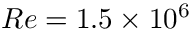Convert formula to latex. <formula><loc_0><loc_0><loc_500><loc_500>R e = 1 . 5 \times 1 0 ^ { 6 }</formula> 